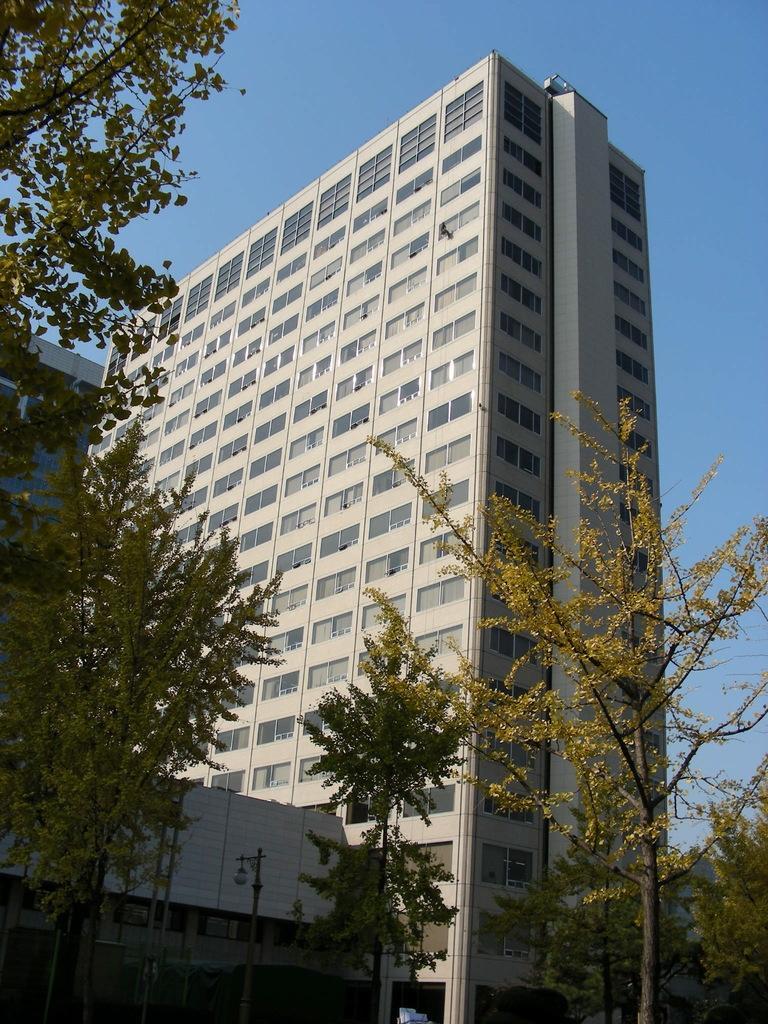Describe this image in one or two sentences. In this image there are buildings, few trees and the sky. 